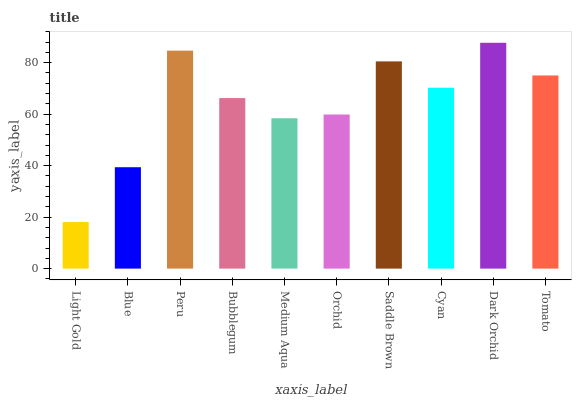Is Light Gold the minimum?
Answer yes or no. Yes. Is Dark Orchid the maximum?
Answer yes or no. Yes. Is Blue the minimum?
Answer yes or no. No. Is Blue the maximum?
Answer yes or no. No. Is Blue greater than Light Gold?
Answer yes or no. Yes. Is Light Gold less than Blue?
Answer yes or no. Yes. Is Light Gold greater than Blue?
Answer yes or no. No. Is Blue less than Light Gold?
Answer yes or no. No. Is Cyan the high median?
Answer yes or no. Yes. Is Bubblegum the low median?
Answer yes or no. Yes. Is Saddle Brown the high median?
Answer yes or no. No. Is Medium Aqua the low median?
Answer yes or no. No. 